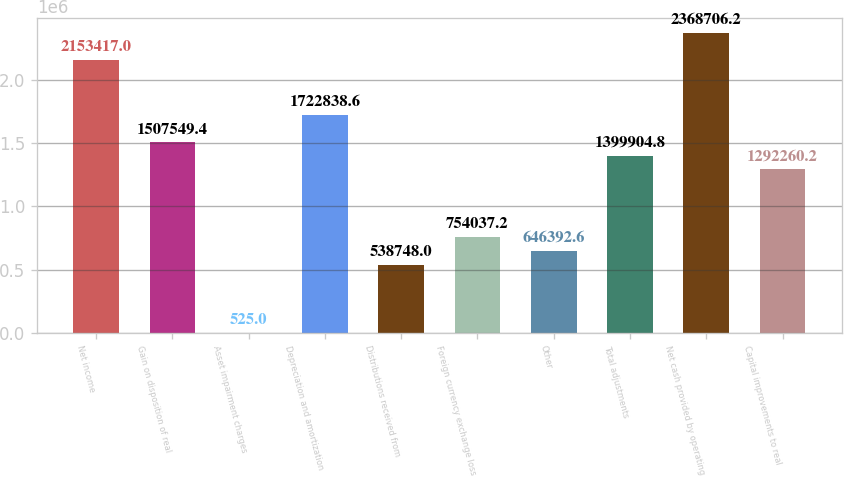<chart> <loc_0><loc_0><loc_500><loc_500><bar_chart><fcel>Net income<fcel>Gain on disposition of real<fcel>Asset impairment charges<fcel>Depreciation and amortization<fcel>Distributions received from<fcel>Foreign currency exchange loss<fcel>Other<fcel>Total adjustments<fcel>Net cash provided by operating<fcel>Capital improvements to real<nl><fcel>2.15342e+06<fcel>1.50755e+06<fcel>525<fcel>1.72284e+06<fcel>538748<fcel>754037<fcel>646393<fcel>1.3999e+06<fcel>2.36871e+06<fcel>1.29226e+06<nl></chart> 